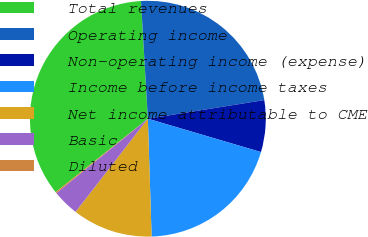Convert chart to OTSL. <chart><loc_0><loc_0><loc_500><loc_500><pie_chart><fcel>Total revenues<fcel>Operating income<fcel>Non-operating income (expense)<fcel>Income before income taxes<fcel>Net income attributable to CME<fcel>Basic<fcel>Diluted<nl><fcel>34.77%<fcel>23.4%<fcel>7.09%<fcel>19.93%<fcel>11.01%<fcel>3.63%<fcel>0.17%<nl></chart> 